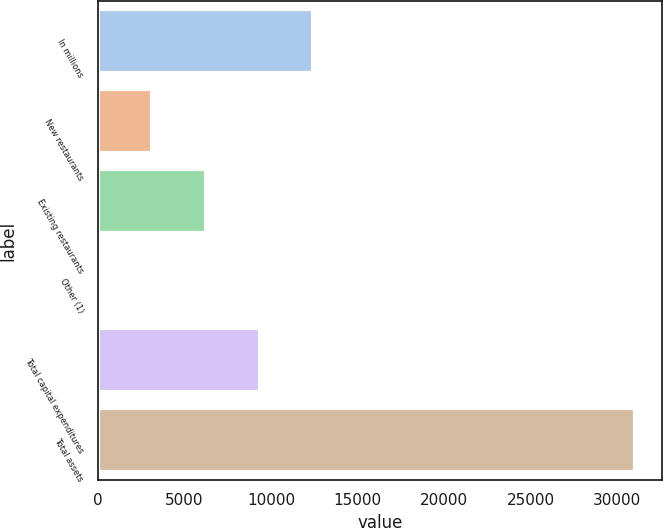<chart> <loc_0><loc_0><loc_500><loc_500><bar_chart><fcel>In millions<fcel>New restaurants<fcel>Existing restaurants<fcel>Other (1)<fcel>Total capital expenditures<fcel>Total assets<nl><fcel>12433<fcel>3137.5<fcel>6236<fcel>39<fcel>9334.5<fcel>31024<nl></chart> 